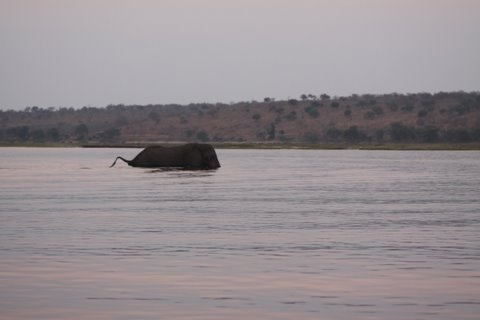Describe the objects in this image and their specific colors. I can see a elephant in darkgray, black, and gray tones in this image. 